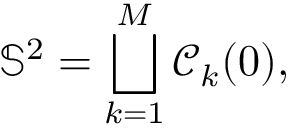<formula> <loc_0><loc_0><loc_500><loc_500>\mathbb { S } ^ { 2 } = \bigsqcup _ { k = 1 } ^ { M } \ m a t h s c r { C } _ { k } ( 0 ) ,</formula> 